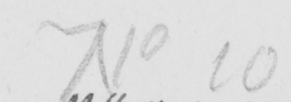Please provide the text content of this handwritten line. No 10 